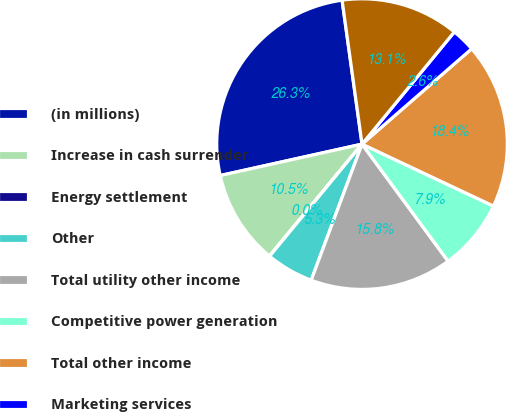Convert chart. <chart><loc_0><loc_0><loc_500><loc_500><pie_chart><fcel>(in millions)<fcel>Increase in cash surrender<fcel>Energy settlement<fcel>Other<fcel>Total utility other income<fcel>Competitive power generation<fcel>Total other income<fcel>Marketing services<fcel>Total utility other expenses<nl><fcel>26.28%<fcel>10.53%<fcel>0.03%<fcel>5.28%<fcel>15.78%<fcel>7.9%<fcel>18.4%<fcel>2.65%<fcel>13.15%<nl></chart> 